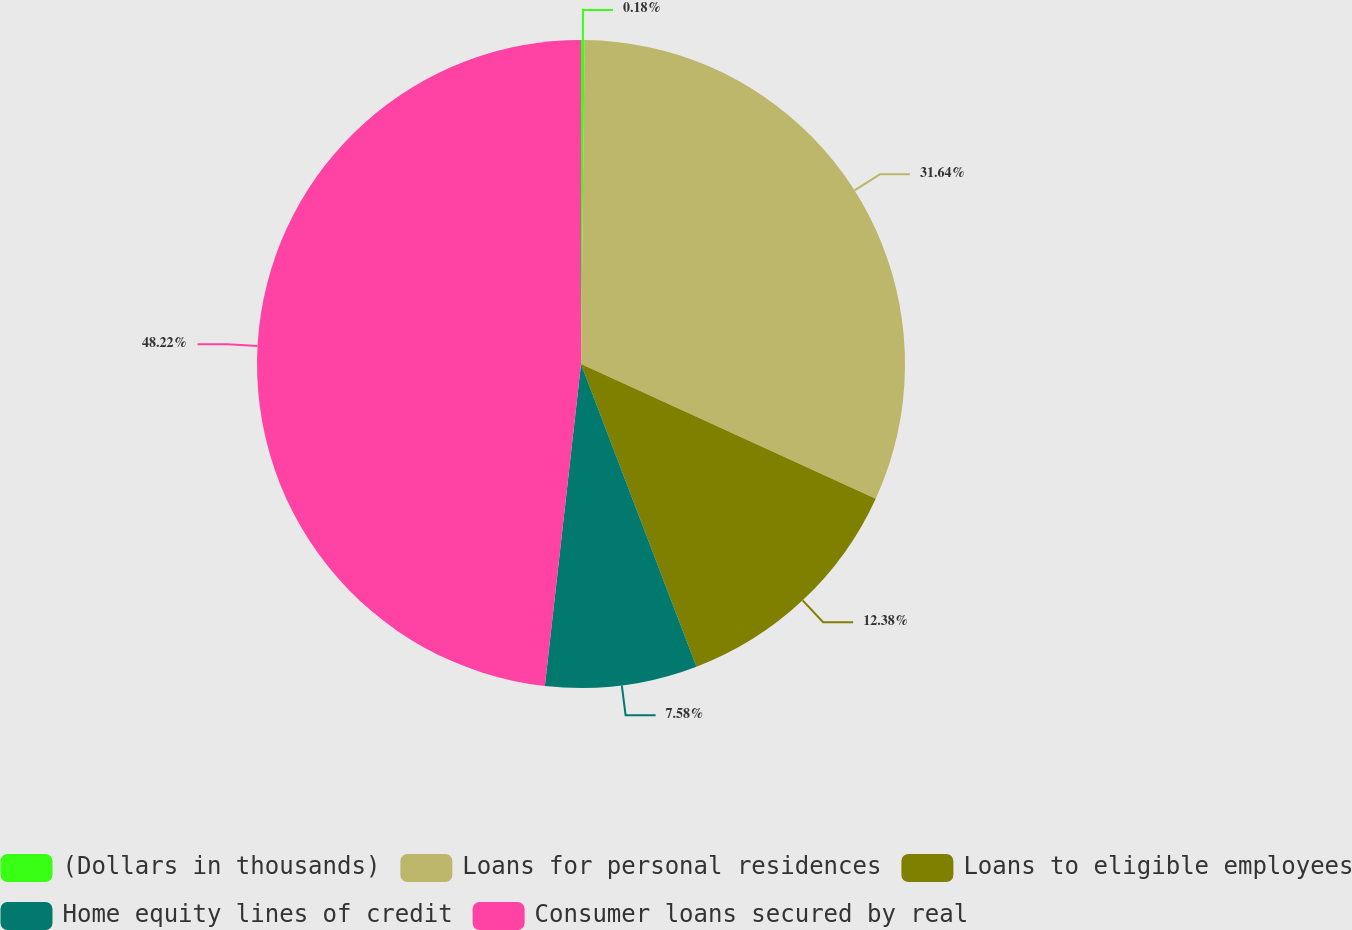Convert chart to OTSL. <chart><loc_0><loc_0><loc_500><loc_500><pie_chart><fcel>(Dollars in thousands)<fcel>Loans for personal residences<fcel>Loans to eligible employees<fcel>Home equity lines of credit<fcel>Consumer loans secured by real<nl><fcel>0.18%<fcel>31.64%<fcel>12.38%<fcel>7.58%<fcel>48.22%<nl></chart> 